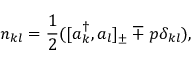<formula> <loc_0><loc_0><loc_500><loc_500>n _ { k l } = \frac { 1 } { 2 } ( [ a _ { k } ^ { \dagger } , a _ { l } ] _ { \pm } \mp p \delta _ { k l } ) ,</formula> 